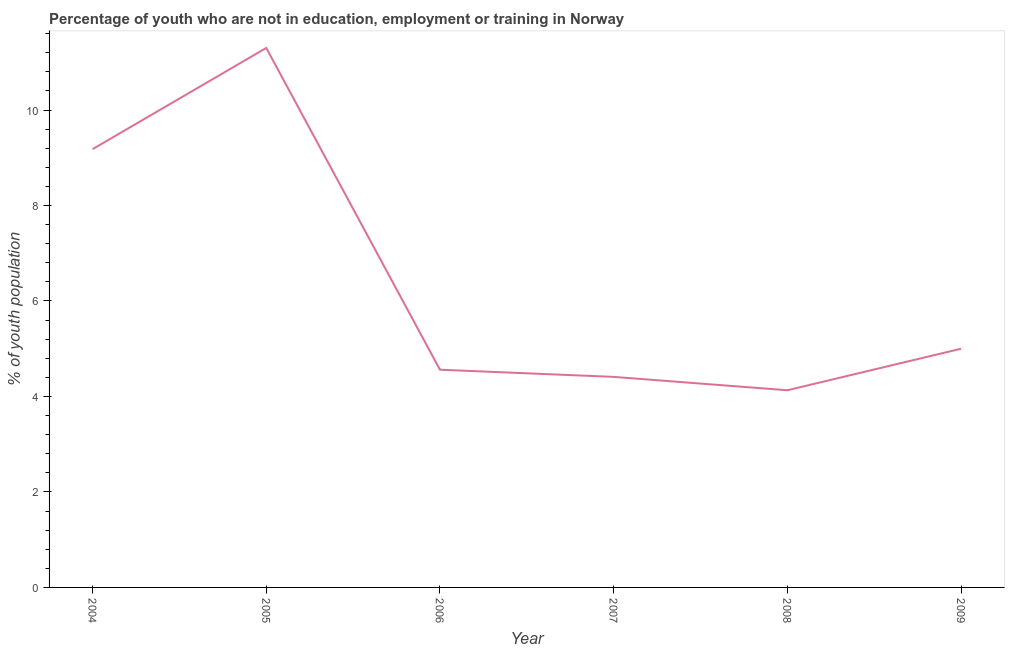What is the unemployed youth population in 2007?
Provide a succinct answer. 4.41. Across all years, what is the maximum unemployed youth population?
Give a very brief answer. 11.3. Across all years, what is the minimum unemployed youth population?
Keep it short and to the point. 4.13. In which year was the unemployed youth population maximum?
Make the answer very short. 2005. What is the sum of the unemployed youth population?
Keep it short and to the point. 38.58. What is the difference between the unemployed youth population in 2007 and 2008?
Your response must be concise. 0.28. What is the average unemployed youth population per year?
Your response must be concise. 6.43. What is the median unemployed youth population?
Provide a short and direct response. 4.78. In how many years, is the unemployed youth population greater than 11.2 %?
Keep it short and to the point. 1. What is the ratio of the unemployed youth population in 2005 to that in 2009?
Make the answer very short. 2.26. Is the difference between the unemployed youth population in 2004 and 2008 greater than the difference between any two years?
Your answer should be compact. No. What is the difference between the highest and the second highest unemployed youth population?
Offer a terse response. 2.12. Is the sum of the unemployed youth population in 2005 and 2006 greater than the maximum unemployed youth population across all years?
Keep it short and to the point. Yes. What is the difference between the highest and the lowest unemployed youth population?
Provide a short and direct response. 7.17. In how many years, is the unemployed youth population greater than the average unemployed youth population taken over all years?
Offer a very short reply. 2. What is the difference between two consecutive major ticks on the Y-axis?
Provide a short and direct response. 2. Does the graph contain grids?
Keep it short and to the point. No. What is the title of the graph?
Offer a very short reply. Percentage of youth who are not in education, employment or training in Norway. What is the label or title of the X-axis?
Offer a terse response. Year. What is the label or title of the Y-axis?
Your response must be concise. % of youth population. What is the % of youth population in 2004?
Your answer should be compact. 9.18. What is the % of youth population of 2005?
Provide a succinct answer. 11.3. What is the % of youth population of 2006?
Offer a terse response. 4.56. What is the % of youth population of 2007?
Your response must be concise. 4.41. What is the % of youth population of 2008?
Provide a short and direct response. 4.13. What is the % of youth population of 2009?
Your response must be concise. 5. What is the difference between the % of youth population in 2004 and 2005?
Offer a terse response. -2.12. What is the difference between the % of youth population in 2004 and 2006?
Provide a short and direct response. 4.62. What is the difference between the % of youth population in 2004 and 2007?
Offer a terse response. 4.77. What is the difference between the % of youth population in 2004 and 2008?
Offer a terse response. 5.05. What is the difference between the % of youth population in 2004 and 2009?
Offer a terse response. 4.18. What is the difference between the % of youth population in 2005 and 2006?
Your response must be concise. 6.74. What is the difference between the % of youth population in 2005 and 2007?
Offer a very short reply. 6.89. What is the difference between the % of youth population in 2005 and 2008?
Your answer should be very brief. 7.17. What is the difference between the % of youth population in 2006 and 2008?
Ensure brevity in your answer.  0.43. What is the difference between the % of youth population in 2006 and 2009?
Your answer should be very brief. -0.44. What is the difference between the % of youth population in 2007 and 2008?
Provide a short and direct response. 0.28. What is the difference between the % of youth population in 2007 and 2009?
Your answer should be compact. -0.59. What is the difference between the % of youth population in 2008 and 2009?
Keep it short and to the point. -0.87. What is the ratio of the % of youth population in 2004 to that in 2005?
Ensure brevity in your answer.  0.81. What is the ratio of the % of youth population in 2004 to that in 2006?
Your response must be concise. 2.01. What is the ratio of the % of youth population in 2004 to that in 2007?
Your answer should be very brief. 2.08. What is the ratio of the % of youth population in 2004 to that in 2008?
Ensure brevity in your answer.  2.22. What is the ratio of the % of youth population in 2004 to that in 2009?
Offer a very short reply. 1.84. What is the ratio of the % of youth population in 2005 to that in 2006?
Your response must be concise. 2.48. What is the ratio of the % of youth population in 2005 to that in 2007?
Offer a terse response. 2.56. What is the ratio of the % of youth population in 2005 to that in 2008?
Keep it short and to the point. 2.74. What is the ratio of the % of youth population in 2005 to that in 2009?
Provide a succinct answer. 2.26. What is the ratio of the % of youth population in 2006 to that in 2007?
Provide a short and direct response. 1.03. What is the ratio of the % of youth population in 2006 to that in 2008?
Offer a very short reply. 1.1. What is the ratio of the % of youth population in 2006 to that in 2009?
Your response must be concise. 0.91. What is the ratio of the % of youth population in 2007 to that in 2008?
Your answer should be very brief. 1.07. What is the ratio of the % of youth population in 2007 to that in 2009?
Your response must be concise. 0.88. What is the ratio of the % of youth population in 2008 to that in 2009?
Give a very brief answer. 0.83. 